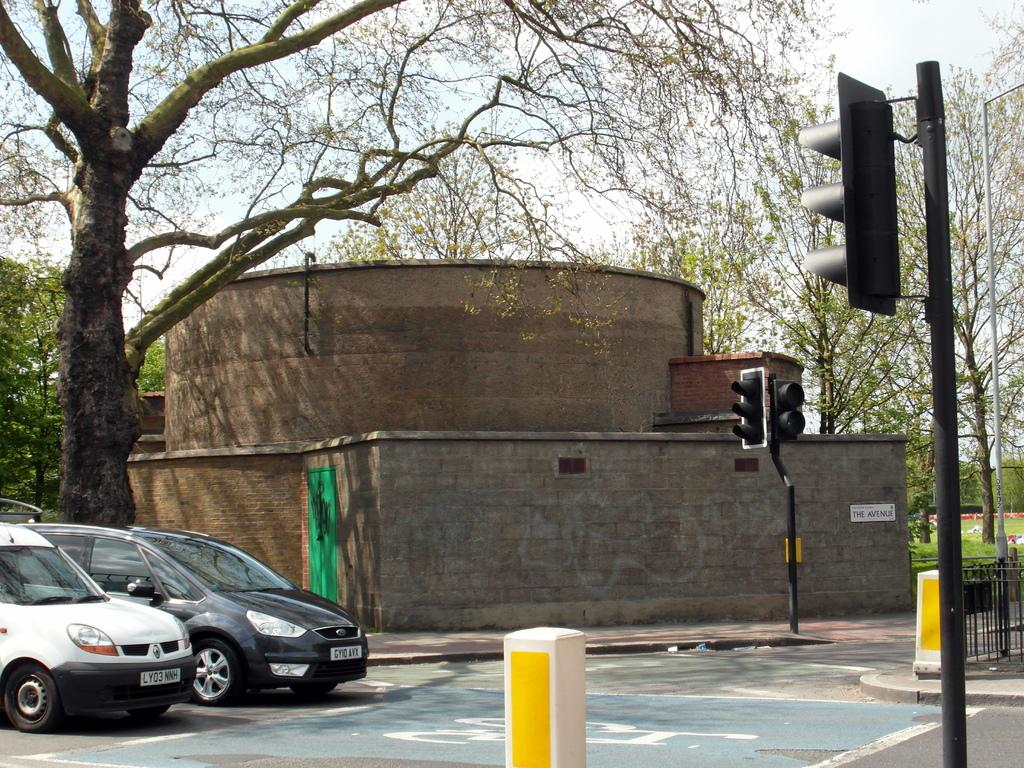What structures are present in the image? There are poles, traffic signals, walls, a fence, and a board in the image. What type of vehicles can be seen on the road in the image? There are vehicles on the road in the image. What natural elements are visible in the image? There are trees, grass, and the sky visible in the image. Can you describe the background of the image? The sky is visible in the background of the image. Reasoning: Let' Let's think step by step in order to produce the conversation. We start by identifying the main structures and elements in the image based on the provided facts. We then formulate questions that focus on the location and characteristics of these structures and elements, ensuring that each question can be answered definitively with the information given. We avoid yes/no questions and ensure that the language is simple and clear. Absurd Question/Answer: How many pizzas are being delivered by the ship in the image? There is no ship or pizzas present in the image. Can you describe the man standing near the traffic signal in the image? There is no man present in the image. How many pizzas are being delivered by the ship in the image? There is no ship or pizzas present in the image. 